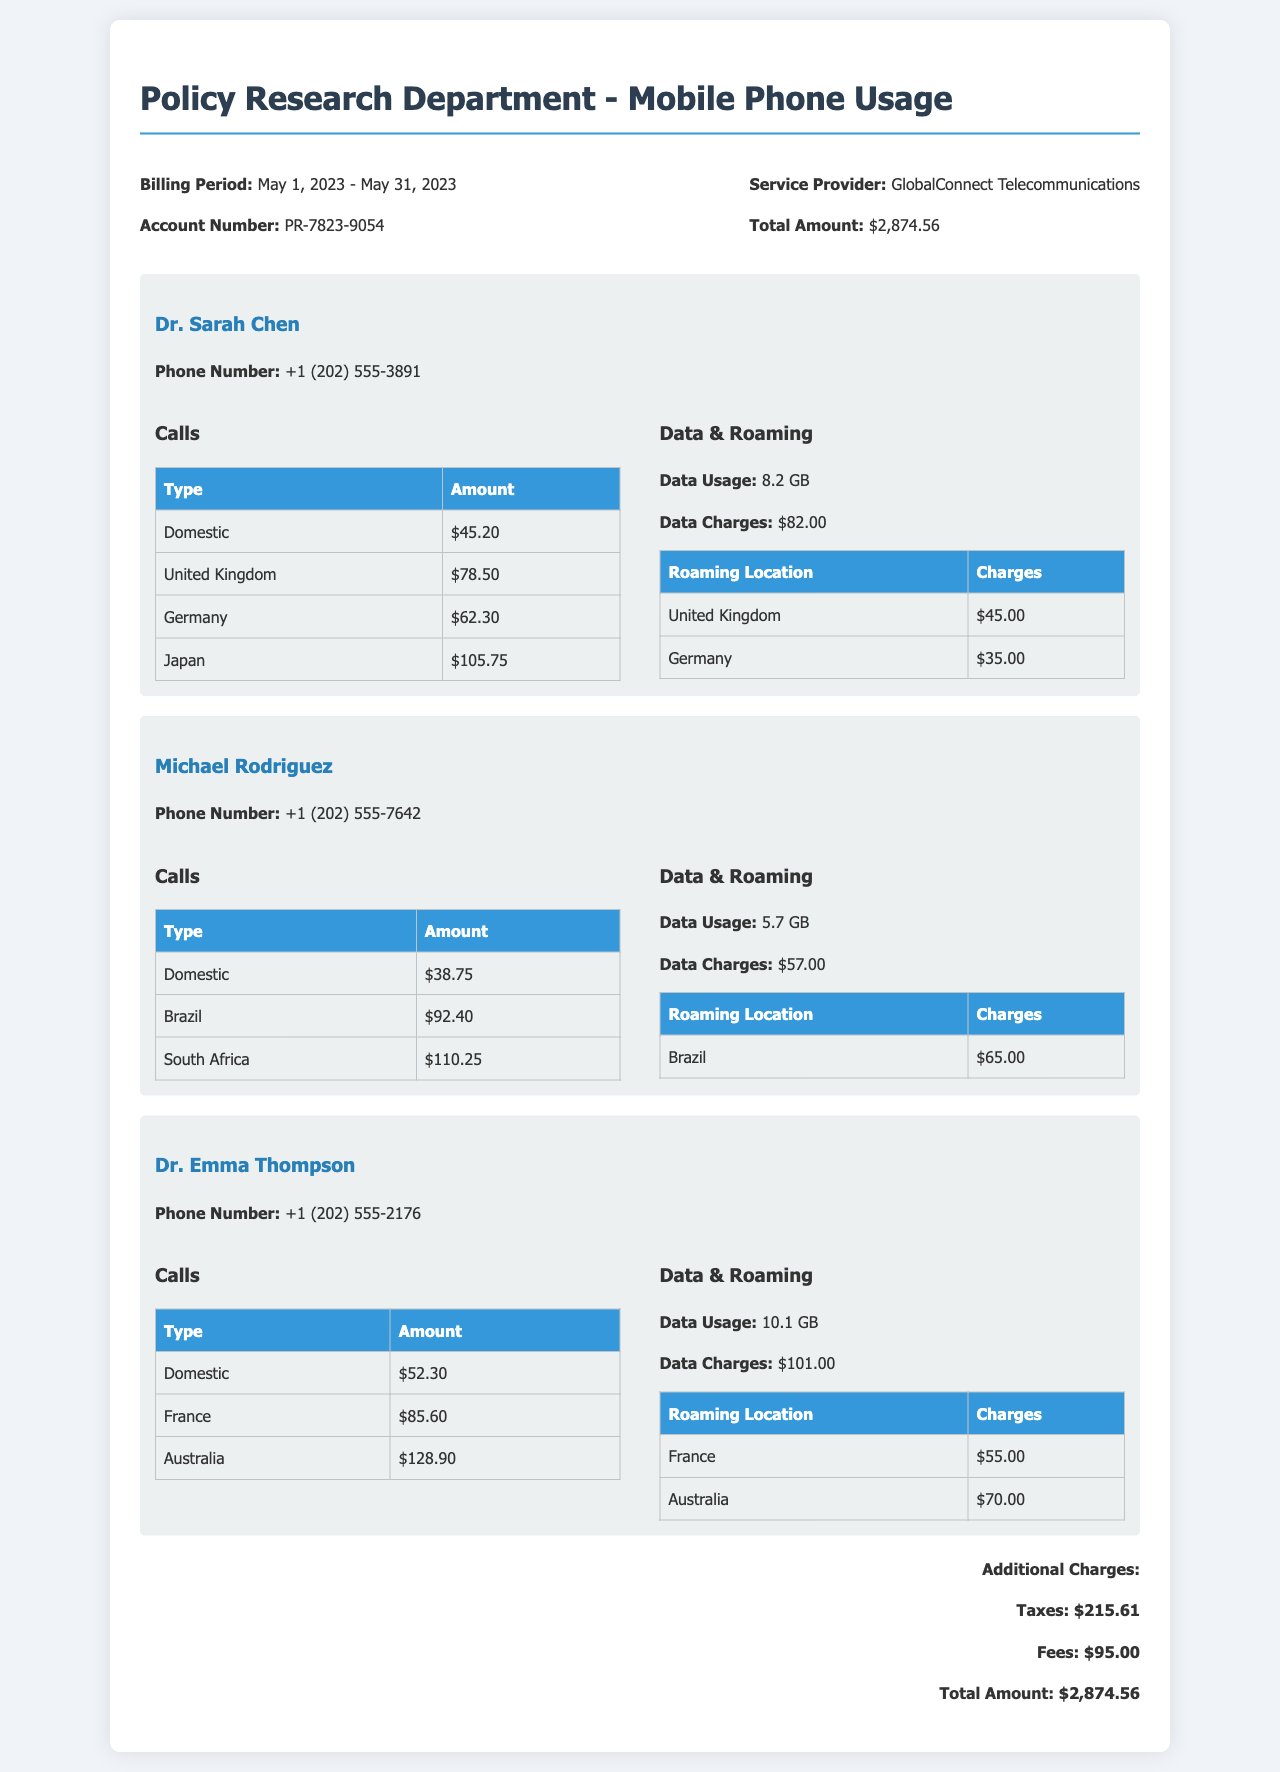What is the billing period? The billing period is specified at the top of the document, covering from May 1, 2023, to May 31, 2023.
Answer: May 1, 2023 - May 31, 2023 How much did Dr. Sarah Chen spend on international calls? The amounts for Dr. Sarah Chen's international calls are listed in the table under "Calls", totaling $78.50 for the UK, $62.30 for Germany, and $105.75 for Japan.
Answer: $246.55 What is the total amount of data charges across all employees? Each employee's data charges are mentioned separately, with Dr. Sarah Chen having $82.00, Michael Rodriguez $57.00, and Dr. Emma Thompson $101.00, totaling these amounts yields the total data charges.
Answer: $240.00 Which employee incurred the highest roaming charges? Roaming charges are listed for each employee, and by comparing the amounts, Dr. Emma Thompson's roaming charges add up to $125.00, which is the highest.
Answer: Dr. Emma Thompson What is the total amount billed including taxes and fees? The document lists the total amount as $2,874.56, which includes additional charges from taxes and fees.
Answer: $2,874.56 What is the service provider's name? The service provider is identified in the header section of the document.
Answer: GlobalConnect Telecommunications 